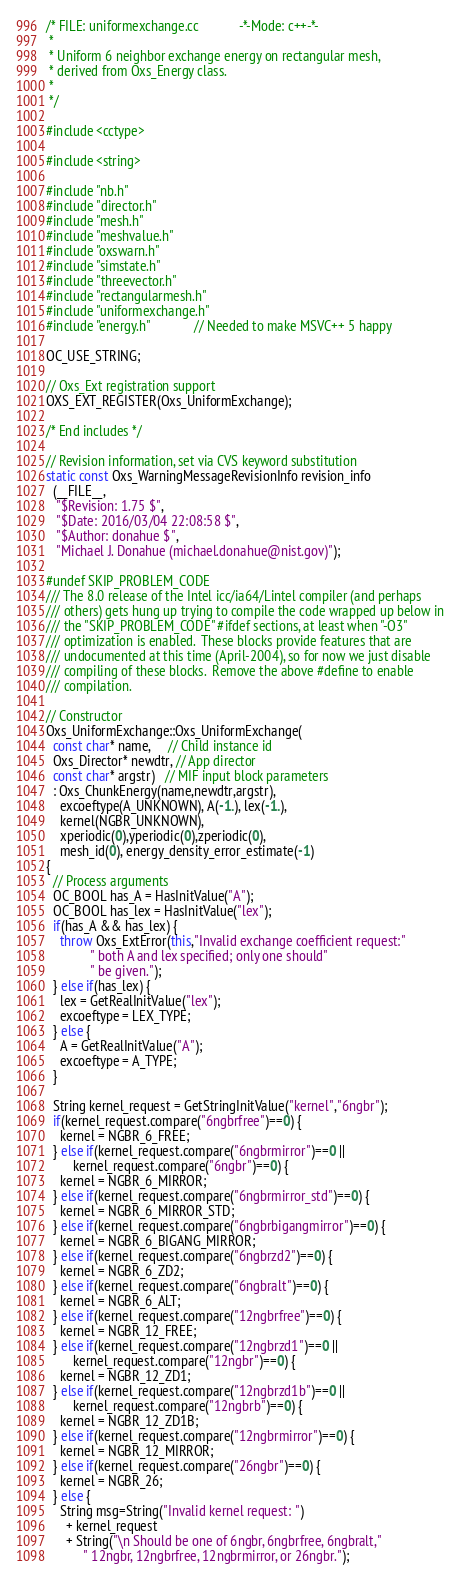<code> <loc_0><loc_0><loc_500><loc_500><_C++_>/* FILE: uniformexchange.cc            -*-Mode: c++-*-
 *
 * Uniform 6 neighbor exchange energy on rectangular mesh,
 * derived from Oxs_Energy class.
 *
 */

#include <cctype>

#include <string>

#include "nb.h"
#include "director.h"
#include "mesh.h"
#include "meshvalue.h"
#include "oxswarn.h"
#include "simstate.h"
#include "threevector.h"
#include "rectangularmesh.h"
#include "uniformexchange.h"
#include "energy.h"             // Needed to make MSVC++ 5 happy

OC_USE_STRING;

// Oxs_Ext registration support
OXS_EXT_REGISTER(Oxs_UniformExchange);

/* End includes */

// Revision information, set via CVS keyword substitution
static const Oxs_WarningMessageRevisionInfo revision_info
  (__FILE__,
   "$Revision: 1.75 $",
   "$Date: 2016/03/04 22:08:58 $",
   "$Author: donahue $",
   "Michael J. Donahue (michael.donahue@nist.gov)");

#undef SKIP_PROBLEM_CODE
/// The 8.0 release of the Intel icc/ia64/Lintel compiler (and perhaps
/// others) gets hung up trying to compile the code wrapped up below in
/// the "SKIP_PROBLEM_CODE" #ifdef sections, at least when "-O3"
/// optimization is enabled.  These blocks provide features that are
/// undocumented at this time (April-2004), so for now we just disable
/// compiling of these blocks.  Remove the above #define to enable
/// compilation.

// Constructor
Oxs_UniformExchange::Oxs_UniformExchange(
  const char* name,     // Child instance id
  Oxs_Director* newdtr, // App director
  const char* argstr)   // MIF input block parameters
  : Oxs_ChunkEnergy(name,newdtr,argstr),
    excoeftype(A_UNKNOWN), A(-1.), lex(-1.),
    kernel(NGBR_UNKNOWN), 
    xperiodic(0),yperiodic(0),zperiodic(0),
    mesh_id(0), energy_density_error_estimate(-1)
{
  // Process arguments
  OC_BOOL has_A = HasInitValue("A");
  OC_BOOL has_lex = HasInitValue("lex");
  if(has_A && has_lex) {
    throw Oxs_ExtError(this,"Invalid exchange coefficient request:"
			 " both A and lex specified; only one should"
			 " be given.");
  } else if(has_lex) {
    lex = GetRealInitValue("lex");
    excoeftype = LEX_TYPE;
  } else {
    A = GetRealInitValue("A");
    excoeftype = A_TYPE;
  }

  String kernel_request = GetStringInitValue("kernel","6ngbr");
  if(kernel_request.compare("6ngbrfree")==0) {
    kernel = NGBR_6_FREE;
  } else if(kernel_request.compare("6ngbrmirror")==0 ||
	    kernel_request.compare("6ngbr")==0) {
    kernel = NGBR_6_MIRROR;
  } else if(kernel_request.compare("6ngbrmirror_std")==0) {
    kernel = NGBR_6_MIRROR_STD;
  } else if(kernel_request.compare("6ngbrbigangmirror")==0) {
    kernel = NGBR_6_BIGANG_MIRROR;
  } else if(kernel_request.compare("6ngbrzd2")==0) {
    kernel = NGBR_6_ZD2;
  } else if(kernel_request.compare("6ngbralt")==0) {
    kernel = NGBR_6_ALT;
  } else if(kernel_request.compare("12ngbrfree")==0) {
    kernel = NGBR_12_FREE;
  } else if(kernel_request.compare("12ngbrzd1")==0 ||
	    kernel_request.compare("12ngbr")==0) {
    kernel = NGBR_12_ZD1;
  } else if(kernel_request.compare("12ngbrzd1b")==0 ||
	    kernel_request.compare("12ngbrb")==0) {
    kernel = NGBR_12_ZD1B;
  } else if(kernel_request.compare("12ngbrmirror")==0) {
    kernel = NGBR_12_MIRROR;
  } else if(kernel_request.compare("26ngbr")==0) {
    kernel = NGBR_26;
  } else {
    String msg=String("Invalid kernel request: ")
      + kernel_request
      + String("\n Should be one of 6ngbr, 6ngbrfree, 6ngbralt,"
	       " 12ngbr, 12ngbrfree, 12ngbrmirror, or 26ngbr.");</code> 